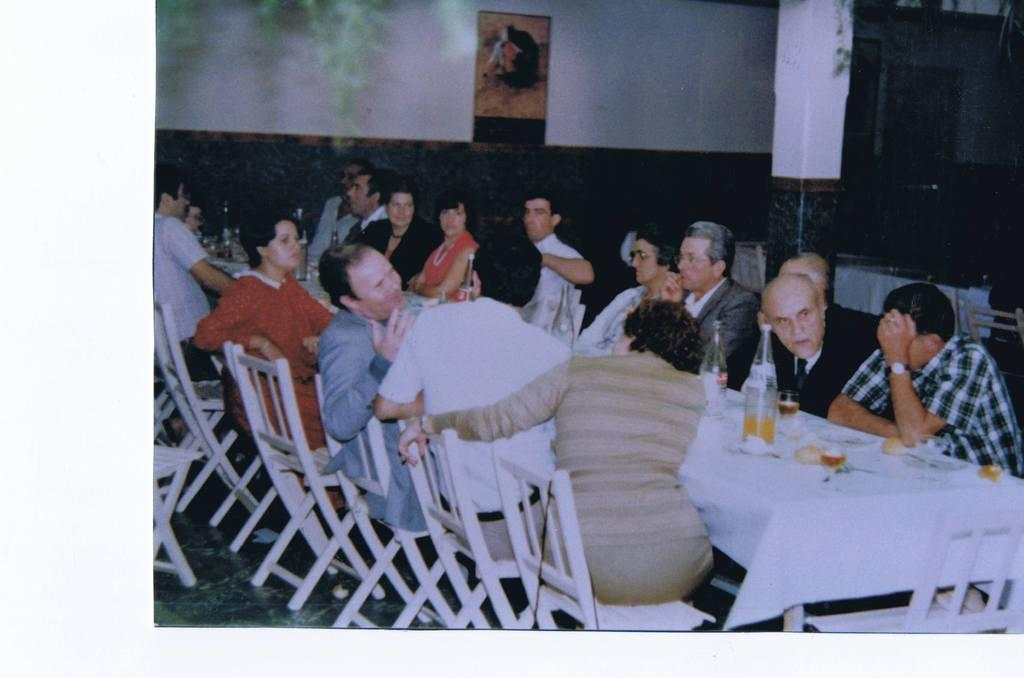What are the people in the image doing? There is a group of people sitting on chairs in the image. What objects can be seen on the table? There is a bottle, a glass, and cloth on the table. What is visible on the wall in the background? There is a poster on the wall in the background. What type of rod is being used by the people in the image? There is no rod present in the image; the people are sitting on chairs. 